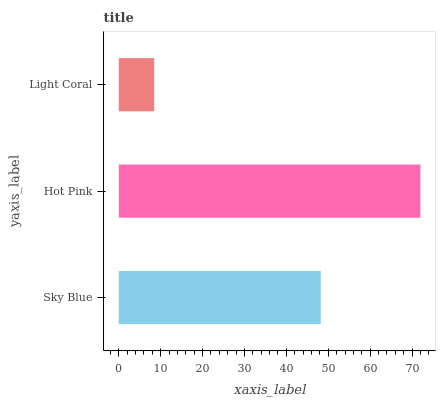Is Light Coral the minimum?
Answer yes or no. Yes. Is Hot Pink the maximum?
Answer yes or no. Yes. Is Hot Pink the minimum?
Answer yes or no. No. Is Light Coral the maximum?
Answer yes or no. No. Is Hot Pink greater than Light Coral?
Answer yes or no. Yes. Is Light Coral less than Hot Pink?
Answer yes or no. Yes. Is Light Coral greater than Hot Pink?
Answer yes or no. No. Is Hot Pink less than Light Coral?
Answer yes or no. No. Is Sky Blue the high median?
Answer yes or no. Yes. Is Sky Blue the low median?
Answer yes or no. Yes. Is Light Coral the high median?
Answer yes or no. No. Is Hot Pink the low median?
Answer yes or no. No. 